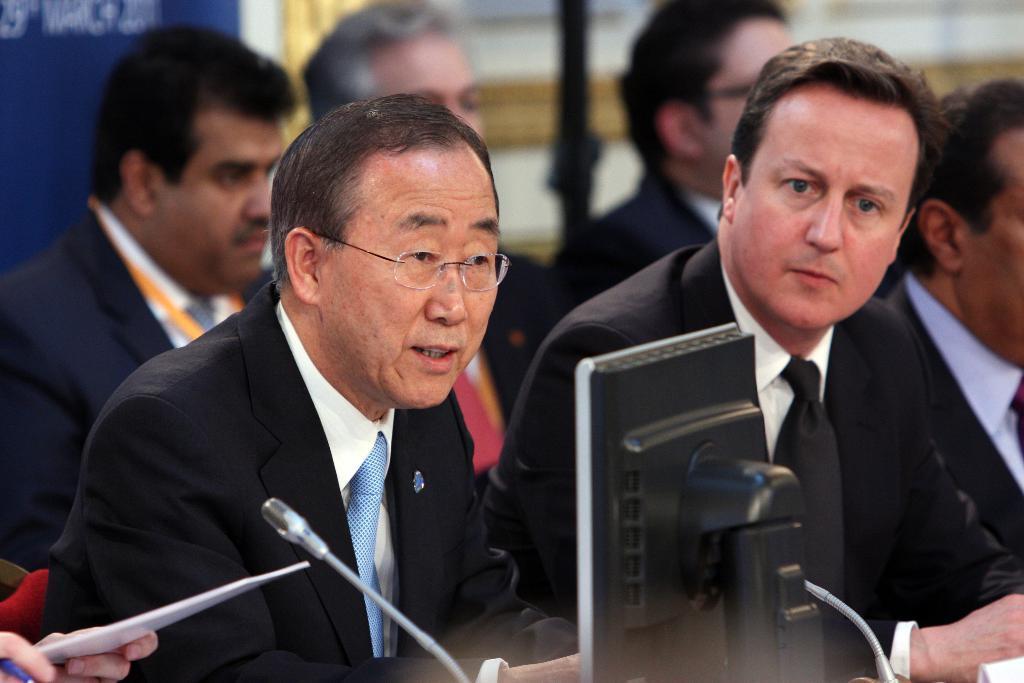Could you give a brief overview of what you see in this image? In this image we can see two people sitting in front a system and microphones, on the bottom left corner a person is holding a sheet and in the background there is a group of people sitting. 